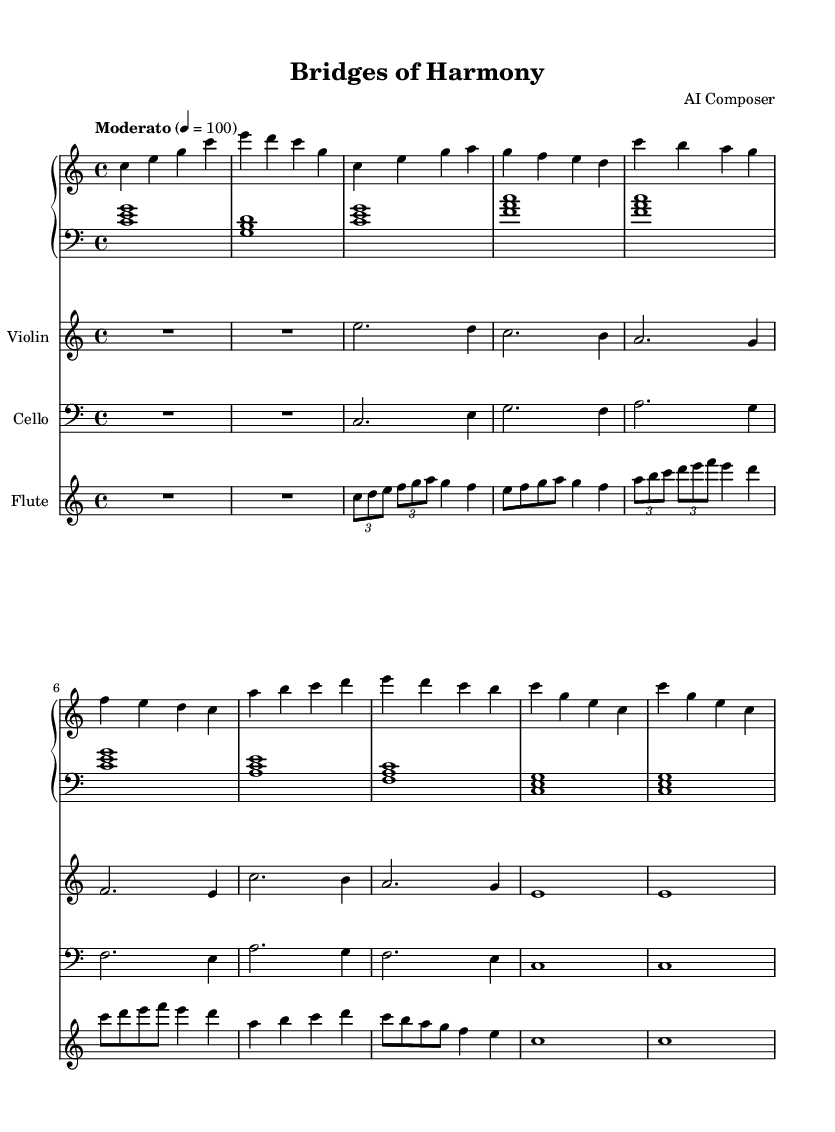What is the key signature of this music? The key signature is C major, which has no sharps or flats.
Answer: C major What is the time signature of this music? The time signature indicates that there are four beats per measure, noted by the "4/4" at the beginning of the score.
Answer: 4/4 What is the tempo marking of this piece? The tempo marking states "Moderato" and indicates a speed of 100 beats per minute, noted by "4 = 100."
Answer: Moderato How many instruments are featured in this score? By counting the individual staves in the score, we can see that there are four instruments: Piano (with right and left hand parts), Violin, Cello, and Flute.
Answer: Four Which part has the highest pitch range? The Violin part has the highest pitch range, as it is written an octave above the other parts and uses notes in a higher register.
Answer: Violin What is the first chord used in the left hand of the piano? The first chord for the left hand is a C major chord, consisting of the notes C, E, and G.
Answer: C major What is the interval between the first two notes in the flute part’s first measure? The interval between the first two notes, C and D, is a whole tone (or major second).
Answer: Whole tone 